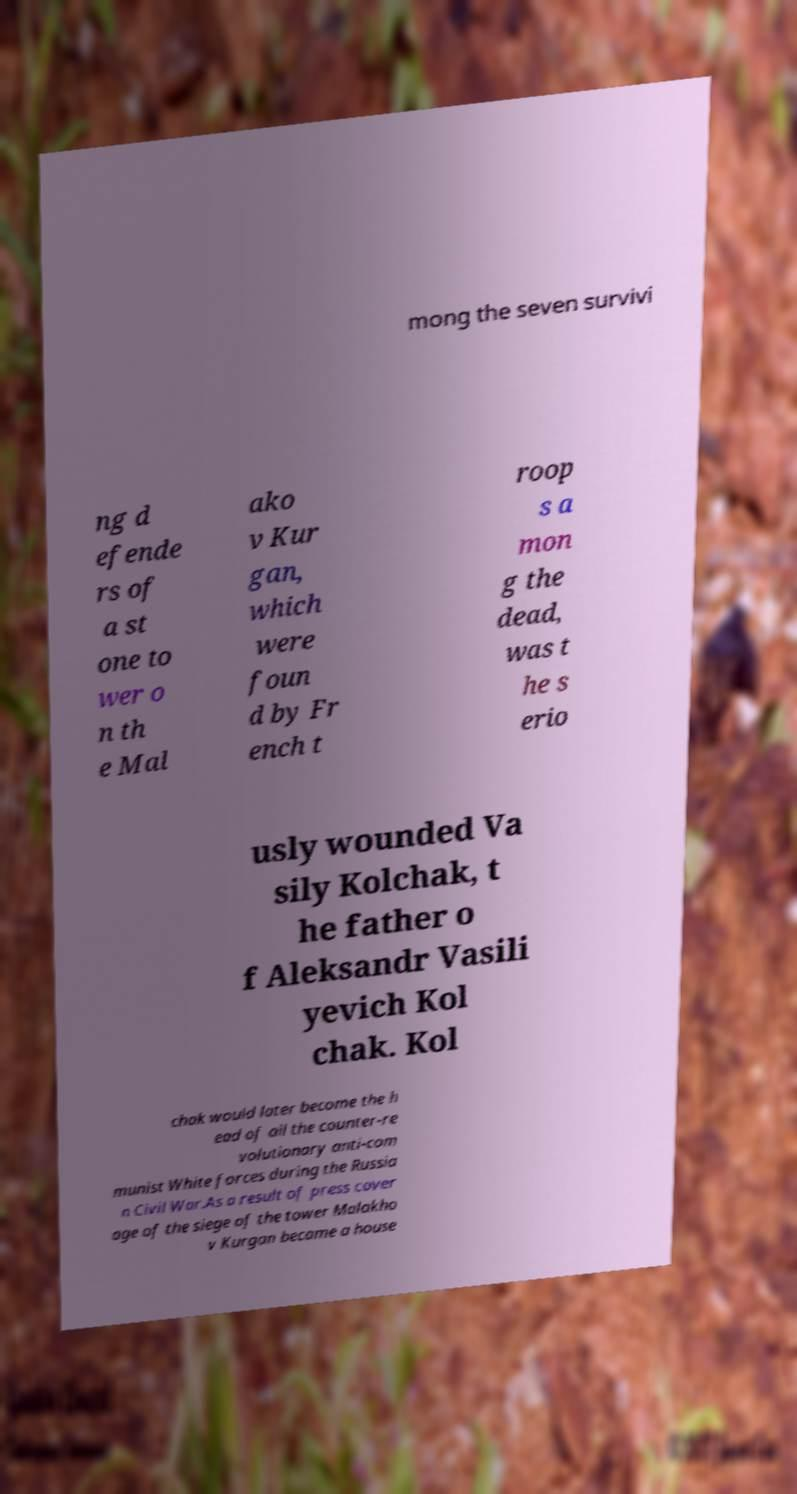Please identify and transcribe the text found in this image. mong the seven survivi ng d efende rs of a st one to wer o n th e Mal ako v Kur gan, which were foun d by Fr ench t roop s a mon g the dead, was t he s erio usly wounded Va sily Kolchak, t he father o f Aleksandr Vasili yevich Kol chak. Kol chak would later become the h ead of all the counter-re volutionary anti-com munist White forces during the Russia n Civil War.As a result of press cover age of the siege of the tower Malakho v Kurgan became a house 